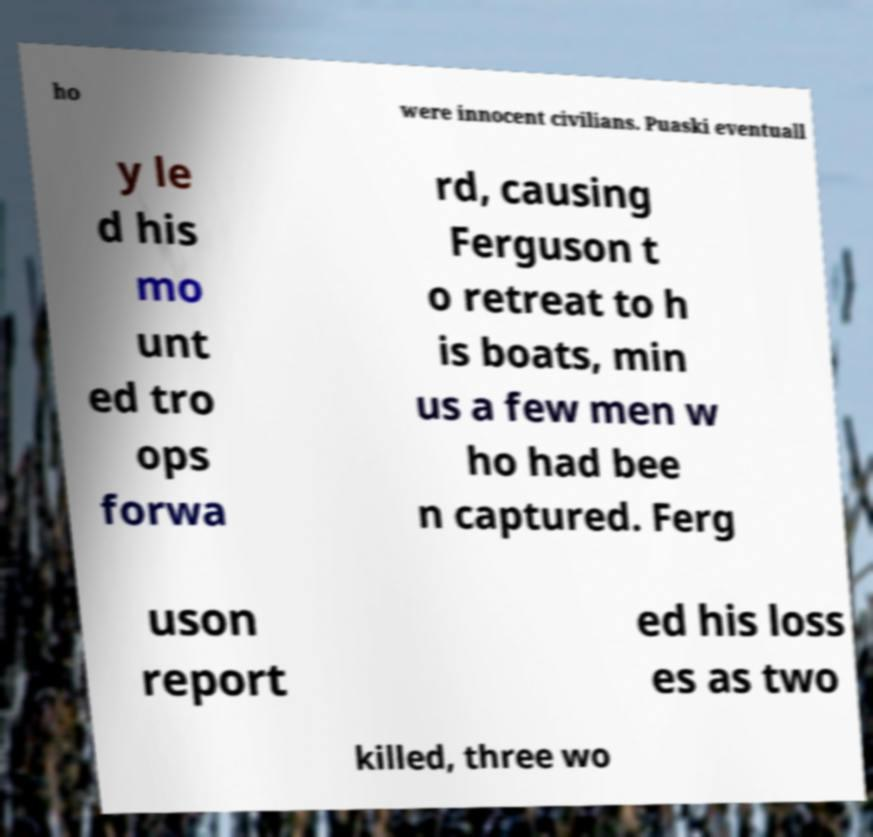What messages or text are displayed in this image? I need them in a readable, typed format. ho were innocent civilians. Puaski eventuall y le d his mo unt ed tro ops forwa rd, causing Ferguson t o retreat to h is boats, min us a few men w ho had bee n captured. Ferg uson report ed his loss es as two killed, three wo 